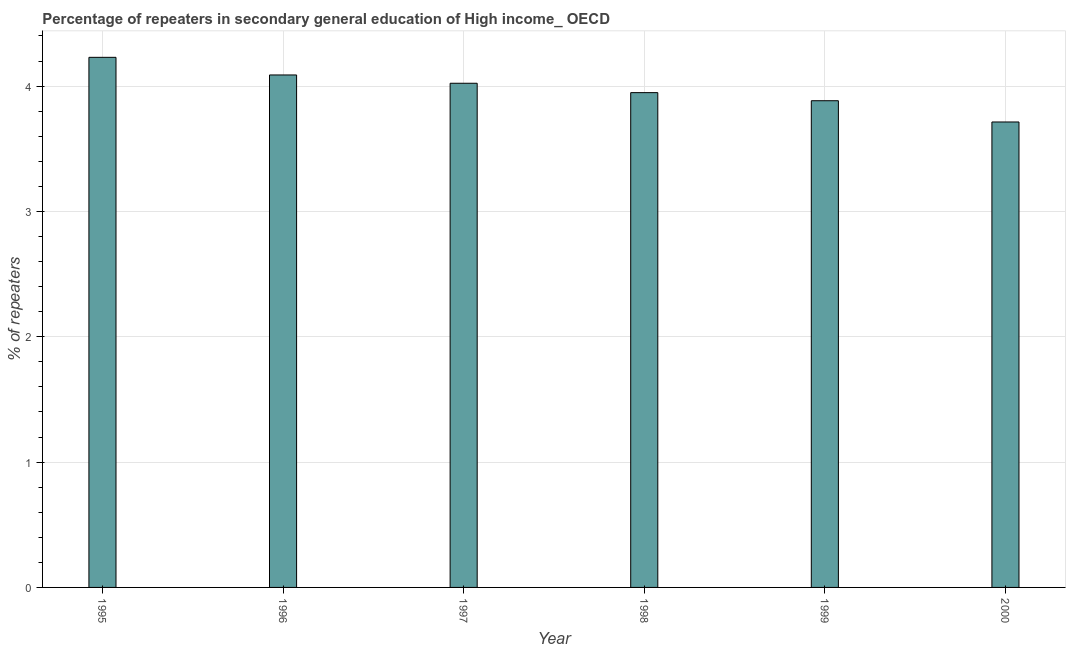Does the graph contain grids?
Your answer should be compact. Yes. What is the title of the graph?
Provide a succinct answer. Percentage of repeaters in secondary general education of High income_ OECD. What is the label or title of the X-axis?
Offer a terse response. Year. What is the label or title of the Y-axis?
Provide a succinct answer. % of repeaters. What is the percentage of repeaters in 1998?
Your answer should be compact. 3.95. Across all years, what is the maximum percentage of repeaters?
Make the answer very short. 4.23. Across all years, what is the minimum percentage of repeaters?
Offer a very short reply. 3.71. In which year was the percentage of repeaters maximum?
Offer a very short reply. 1995. In which year was the percentage of repeaters minimum?
Provide a succinct answer. 2000. What is the sum of the percentage of repeaters?
Your answer should be very brief. 23.89. What is the difference between the percentage of repeaters in 1995 and 2000?
Your answer should be very brief. 0.52. What is the average percentage of repeaters per year?
Your response must be concise. 3.98. What is the median percentage of repeaters?
Keep it short and to the point. 3.99. In how many years, is the percentage of repeaters greater than 2.8 %?
Keep it short and to the point. 6. What is the ratio of the percentage of repeaters in 1995 to that in 1998?
Offer a terse response. 1.07. Is the percentage of repeaters in 1995 less than that in 1996?
Offer a terse response. No. What is the difference between the highest and the second highest percentage of repeaters?
Ensure brevity in your answer.  0.14. Is the sum of the percentage of repeaters in 1998 and 1999 greater than the maximum percentage of repeaters across all years?
Your response must be concise. Yes. What is the difference between the highest and the lowest percentage of repeaters?
Your answer should be compact. 0.52. What is the difference between two consecutive major ticks on the Y-axis?
Provide a succinct answer. 1. Are the values on the major ticks of Y-axis written in scientific E-notation?
Give a very brief answer. No. What is the % of repeaters of 1995?
Offer a terse response. 4.23. What is the % of repeaters in 1996?
Ensure brevity in your answer.  4.09. What is the % of repeaters in 1997?
Your answer should be very brief. 4.02. What is the % of repeaters in 1998?
Provide a succinct answer. 3.95. What is the % of repeaters of 1999?
Offer a terse response. 3.88. What is the % of repeaters of 2000?
Offer a terse response. 3.71. What is the difference between the % of repeaters in 1995 and 1996?
Give a very brief answer. 0.14. What is the difference between the % of repeaters in 1995 and 1997?
Give a very brief answer. 0.21. What is the difference between the % of repeaters in 1995 and 1998?
Your response must be concise. 0.28. What is the difference between the % of repeaters in 1995 and 1999?
Your answer should be compact. 0.35. What is the difference between the % of repeaters in 1995 and 2000?
Keep it short and to the point. 0.52. What is the difference between the % of repeaters in 1996 and 1997?
Your answer should be very brief. 0.07. What is the difference between the % of repeaters in 1996 and 1998?
Your answer should be compact. 0.14. What is the difference between the % of repeaters in 1996 and 1999?
Make the answer very short. 0.21. What is the difference between the % of repeaters in 1996 and 2000?
Offer a terse response. 0.38. What is the difference between the % of repeaters in 1997 and 1998?
Make the answer very short. 0.07. What is the difference between the % of repeaters in 1997 and 1999?
Your answer should be very brief. 0.14. What is the difference between the % of repeaters in 1997 and 2000?
Offer a very short reply. 0.31. What is the difference between the % of repeaters in 1998 and 1999?
Ensure brevity in your answer.  0.06. What is the difference between the % of repeaters in 1998 and 2000?
Provide a short and direct response. 0.23. What is the difference between the % of repeaters in 1999 and 2000?
Your answer should be compact. 0.17. What is the ratio of the % of repeaters in 1995 to that in 1996?
Your response must be concise. 1.03. What is the ratio of the % of repeaters in 1995 to that in 1997?
Provide a succinct answer. 1.05. What is the ratio of the % of repeaters in 1995 to that in 1998?
Provide a succinct answer. 1.07. What is the ratio of the % of repeaters in 1995 to that in 1999?
Your answer should be compact. 1.09. What is the ratio of the % of repeaters in 1995 to that in 2000?
Offer a very short reply. 1.14. What is the ratio of the % of repeaters in 1996 to that in 1997?
Your answer should be very brief. 1.02. What is the ratio of the % of repeaters in 1996 to that in 1998?
Make the answer very short. 1.04. What is the ratio of the % of repeaters in 1996 to that in 1999?
Give a very brief answer. 1.05. What is the ratio of the % of repeaters in 1996 to that in 2000?
Your answer should be compact. 1.1. What is the ratio of the % of repeaters in 1997 to that in 1998?
Make the answer very short. 1.02. What is the ratio of the % of repeaters in 1997 to that in 1999?
Your answer should be compact. 1.04. What is the ratio of the % of repeaters in 1997 to that in 2000?
Give a very brief answer. 1.08. What is the ratio of the % of repeaters in 1998 to that in 1999?
Give a very brief answer. 1.02. What is the ratio of the % of repeaters in 1998 to that in 2000?
Provide a short and direct response. 1.06. What is the ratio of the % of repeaters in 1999 to that in 2000?
Make the answer very short. 1.05. 